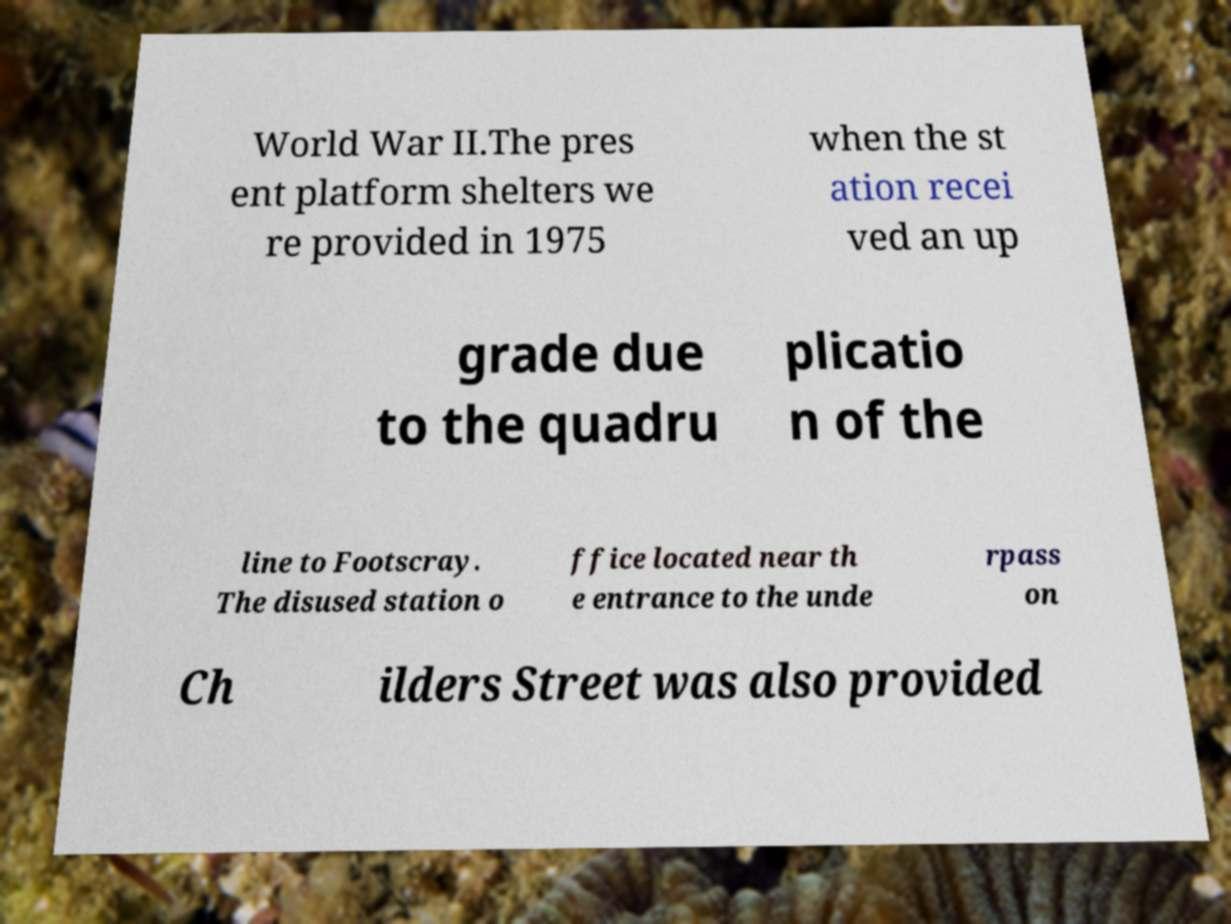Could you assist in decoding the text presented in this image and type it out clearly? World War II.The pres ent platform shelters we re provided in 1975 when the st ation recei ved an up grade due to the quadru plicatio n of the line to Footscray. The disused station o ffice located near th e entrance to the unde rpass on Ch ilders Street was also provided 